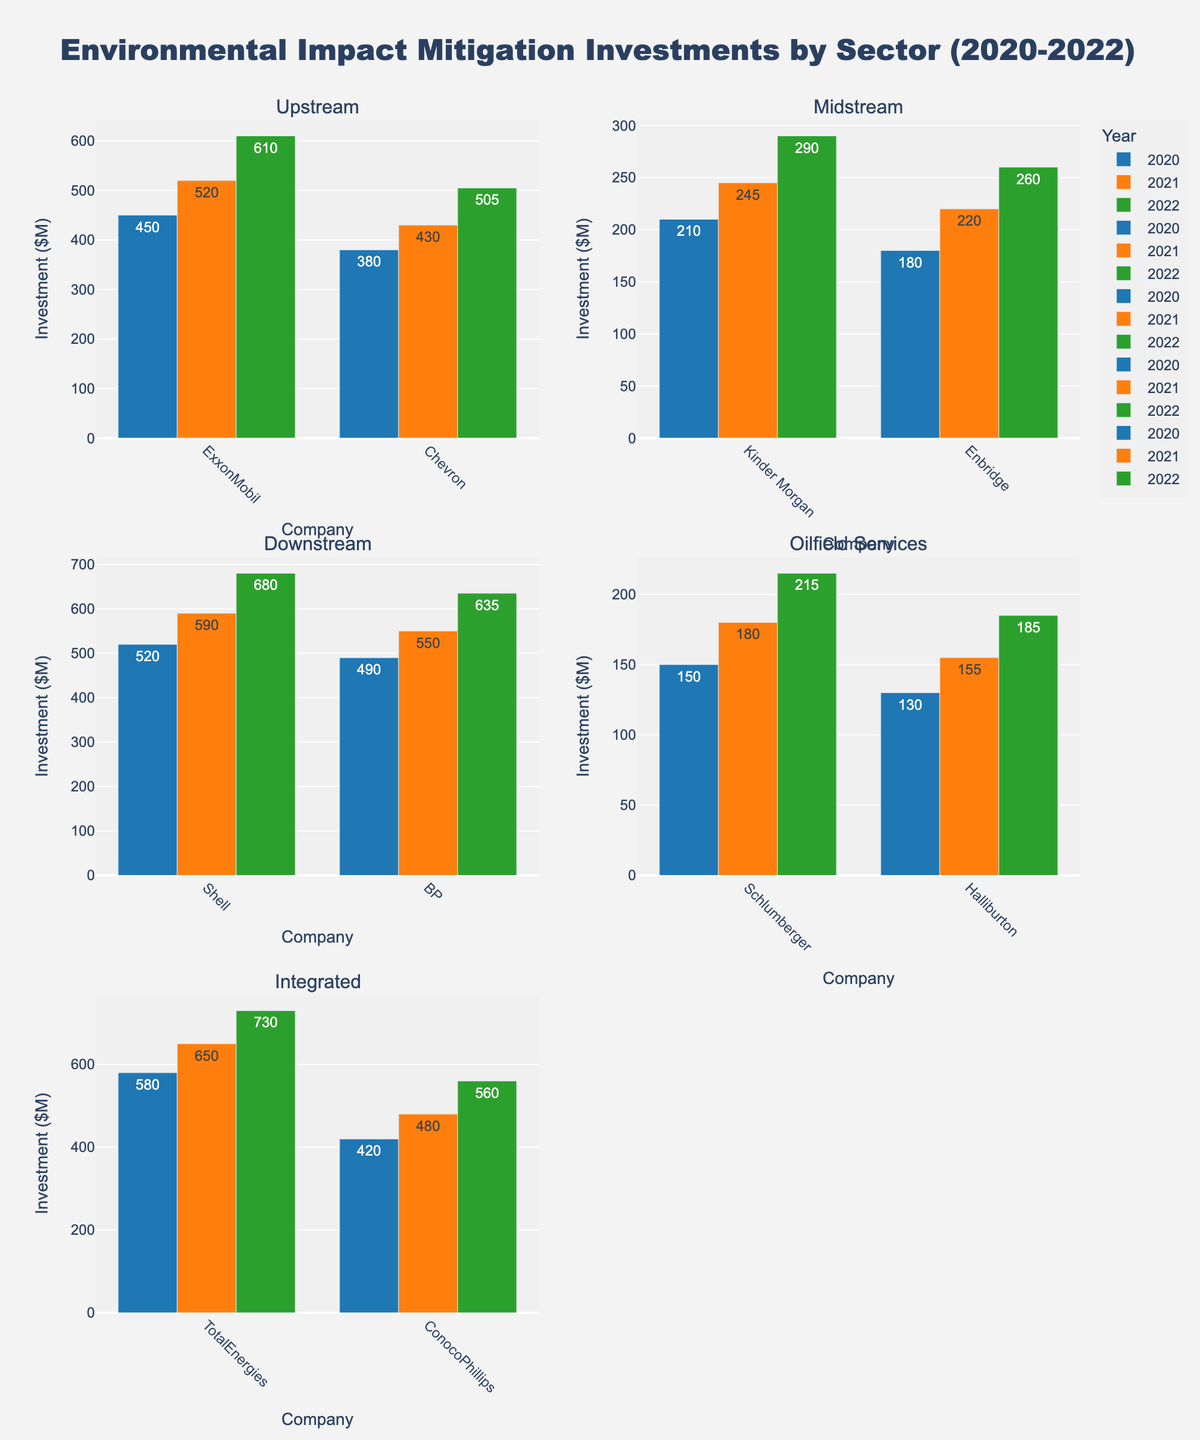How many intersections are shown in the scatter plot? Count the number of data points (markers) visible in the scatter plot. Each marker represents an intersection.
Answer: 10 Which intersection has the highest number of traffic violations per month? Identify the marker on the scatter plot with the highest x-axis value, which corresponds to traffic violations. The hover information for the marker will reveal the intersection name.
Answer: Highland Dr & Lakeview Pkwy What is the title of the figure? The title can be read directly from the top of the figure.
Answer: Traffic Violations and Accident Rates at Major Intersections What is the average number of accidents per month at these intersections? Sum all the accidents per month values and divide by the total number of intersections. The values are 8 + 5 + 7 + 4 + 10 + 3 + 6 + 9 + 5 + 4. The total sum is 61, and the number of intersections is 10, so the average is 61/10.
Answer: 6.1 Which intersection has the highest number of accidents per month? Identify the bar in the bar plot with the highest y-axis value, which represents the number of accidents. The label on the x-axis will reveal the intersection name.
Answer: Highland Dr & Lakeview Pkwy How does the number of accidents per month at River Rd & Forest Ave compare to 5th Ave & Park Rd? Locate both intersections on the bar plot. Compare the heights of the bars. River Rd & Forest Ave has 3 accidents per month, and 5th Ave & Park Rd has 5 accidents per month.
Answer: River Rd & Forest Ave has fewer accidents Is there a positive correlation between traffic violations and accidents per month? Observe the trend in the scatter plot. As the x-values (violations) increase, the y-values (accidents) also tend to increase. This indicates a positive correlation.
Answer: Yes Which intersection has a higher traffic violation rate: Central Blvd & Oak St or Market St & Commerce Way? Find the markers for both intersections on the scatter plot. Compare their x-axis values (traffic violations). Market St & Commerce Way has a higher value.
Answer: Market St & Commerce Way What is the most common number of accidents per month across all intersections? Identify the most frequent y-axis value for the bars in the bar plot. The most common value appears to be 5, as it repeats for multiple intersections.
Answer: 5 What is the sum of traffic violations per month for University Ave & College Rd and Industrial Pkwy & Tech Blvd? Find the violations per month values for both intersections from the scatter plot's hover information, then add them together. University Ave & College Rd has 30 and Industrial Pkwy & Tech Blvd has 25. The sum is 30 + 25.
Answer: 55 